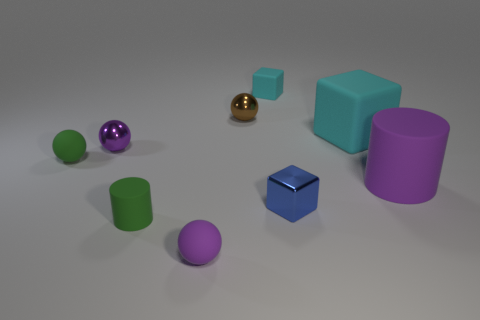The tiny matte object that is the same color as the big rubber cylinder is what shape?
Ensure brevity in your answer.  Sphere. Is the shape of the tiny green matte object that is in front of the tiny green ball the same as the purple matte object that is right of the small brown shiny ball?
Ensure brevity in your answer.  Yes. What number of tiny things are blue metallic cubes or purple metallic balls?
Ensure brevity in your answer.  2. There is a small cyan thing that is made of the same material as the small green ball; what shape is it?
Offer a terse response. Cube. Does the brown object have the same shape as the tiny purple metallic thing?
Your answer should be compact. Yes. The big matte cube is what color?
Your answer should be very brief. Cyan. How many objects are big cylinders or blue shiny objects?
Ensure brevity in your answer.  2. Are there fewer cylinders right of the tiny brown thing than small green things?
Make the answer very short. Yes. Is the number of large cyan rubber cubes that are in front of the tiny purple matte sphere greater than the number of tiny metal things that are to the left of the tiny cyan block?
Make the answer very short. No. Is there anything else that is the same color as the large cylinder?
Your answer should be very brief. Yes. 